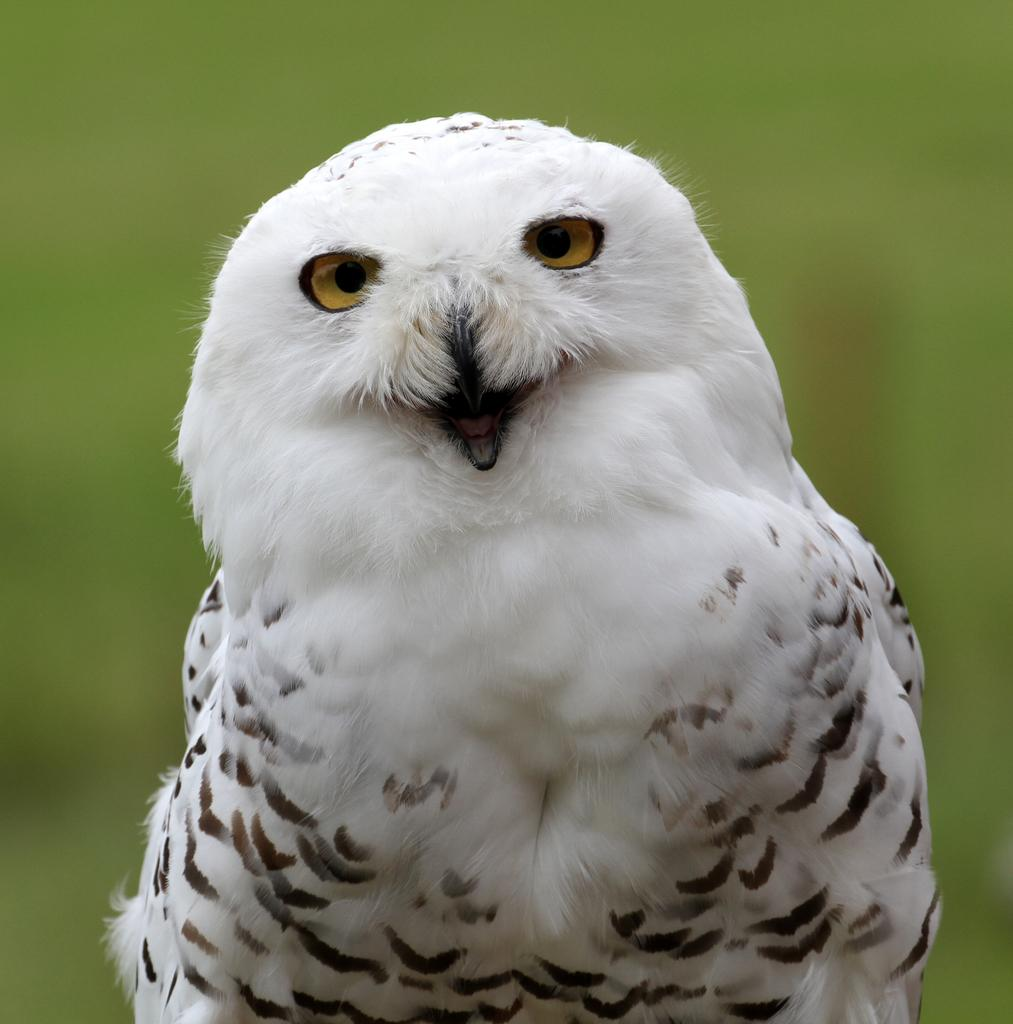What type of animal is in the image? There is an owl in the image. What color combination can be seen on the owl? The owl has a white and black color combination. What is the owl doing in the image? The owl's mouth is open, and it is standing. What color is the background of the image? The background of the image is green. How many pizzas are being digested by the owl in the image? There are no pizzas present in the image, and the owl's digestion is not depicted. What type of lake can be seen in the background of the image? There is no lake present in the image; the background is green. 